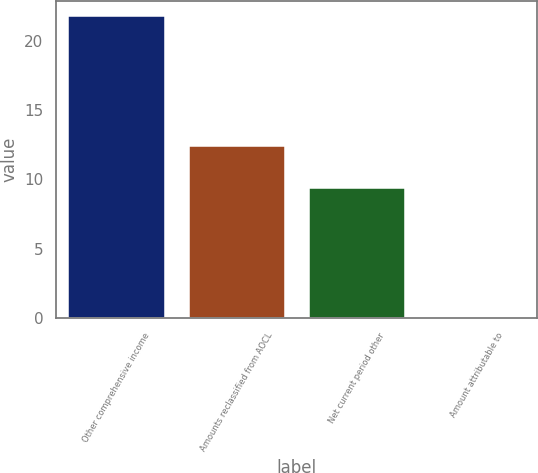Convert chart. <chart><loc_0><loc_0><loc_500><loc_500><bar_chart><fcel>Other comprehensive income<fcel>Amounts reclassified from AOCL<fcel>Net current period other<fcel>Amount attributable to<nl><fcel>21.8<fcel>12.4<fcel>9.4<fcel>0.1<nl></chart> 